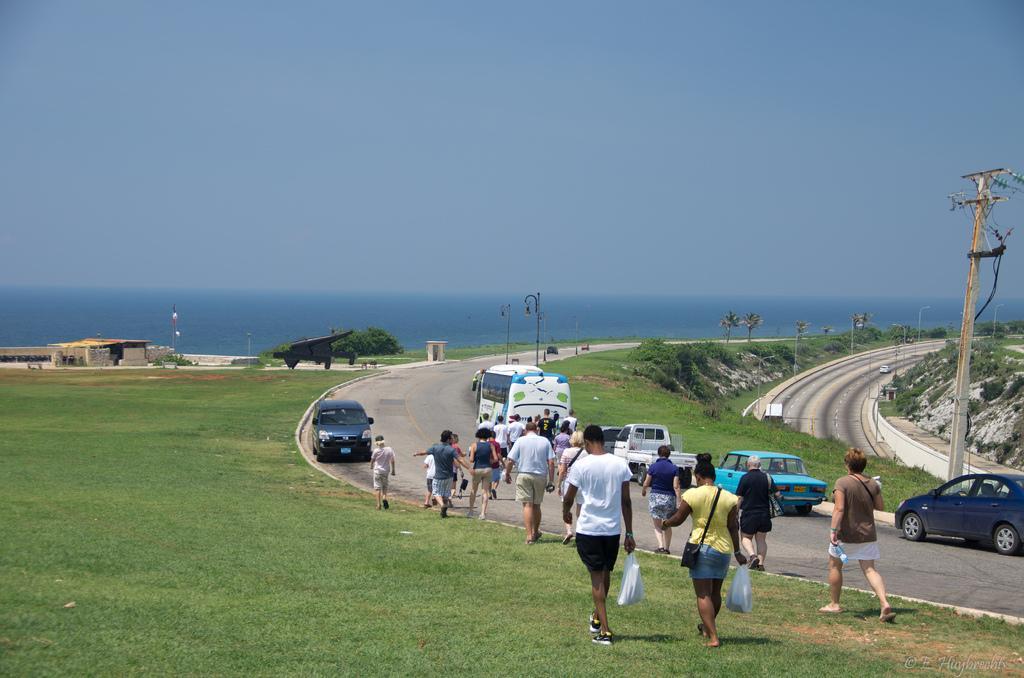How would you summarize this image in a sentence or two? In this image we can see crowd walking on the ground and road, street poles and street lights. In the background we can see road, hills, trees, buildings, water and sea. 